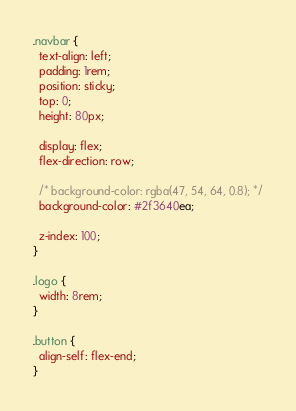Convert code to text. <code><loc_0><loc_0><loc_500><loc_500><_CSS_>.navbar {
  text-align: left;
  padding: 1rem;
  position: sticky;
  top: 0;
  height: 80px;

  display: flex;
  flex-direction: row;

  /* background-color: rgba(47, 54, 64, 0.8); */
  background-color: #2f3640ea;

  z-index: 100;
}

.logo {
  width: 8rem;
}

.button {
  align-self: flex-end;
}
</code> 